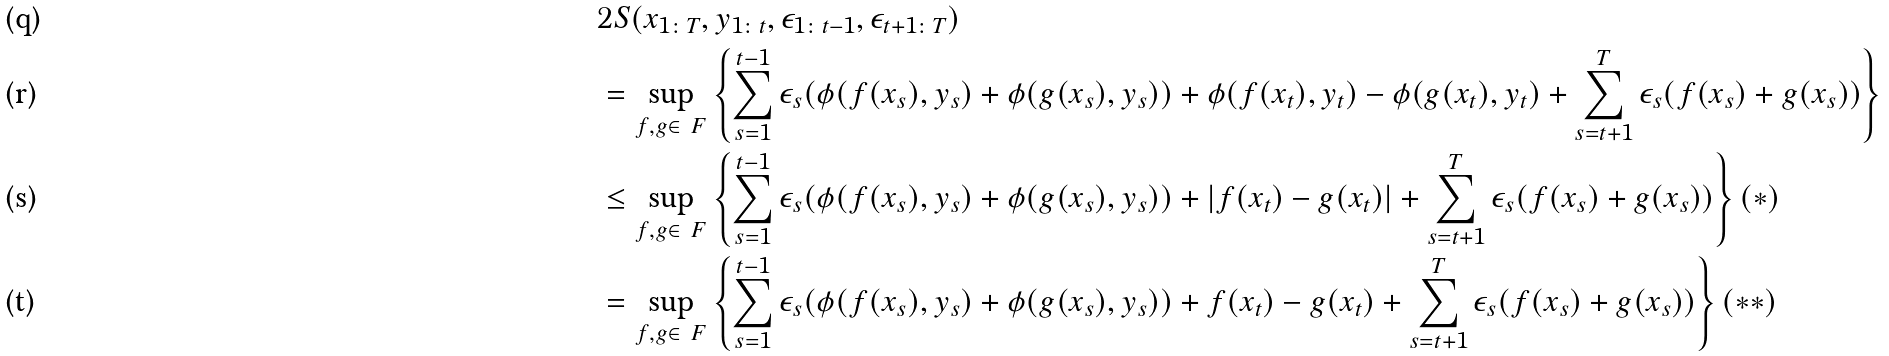<formula> <loc_0><loc_0><loc_500><loc_500>& 2 S ( x _ { 1 \colon T } , y _ { 1 \colon t } , \epsilon _ { 1 \colon t - 1 } , \epsilon _ { t + 1 \colon T } ) \\ & = \sup _ { f , g \in \ F } \left \{ \sum _ { s = 1 } ^ { t - 1 } \epsilon _ { s } ( \phi ( f ( x _ { s } ) , y _ { s } ) + \phi ( g ( x _ { s } ) , y _ { s } ) ) + \phi ( f ( x _ { t } ) , y _ { t } ) - \phi ( g ( x _ { t } ) , y _ { t } ) + \sum _ { s = t + 1 } ^ { T } \epsilon _ { s } ( f ( x _ { s } ) + g ( x _ { s } ) ) \right \} \\ & \leq \sup _ { f , g \in \ F } \left \{ \sum _ { s = 1 } ^ { t - 1 } \epsilon _ { s } ( \phi ( f ( x _ { s } ) , y _ { s } ) + \phi ( g ( x _ { s } ) , y _ { s } ) ) + | f ( x _ { t } ) - g ( x _ { t } ) | + \sum _ { s = t + 1 } ^ { T } \epsilon _ { s } ( f ( x _ { s } ) + g ( x _ { s } ) ) \right \} ( * ) \\ & = \sup _ { f , g \in \ F } \left \{ \sum _ { s = 1 } ^ { t - 1 } \epsilon _ { s } ( \phi ( f ( x _ { s } ) , y _ { s } ) + \phi ( g ( x _ { s } ) , y _ { s } ) ) + f ( x _ { t } ) - g ( x _ { t } ) + \sum _ { s = t + 1 } ^ { T } \epsilon _ { s } ( f ( x _ { s } ) + g ( x _ { s } ) ) \right \} ( * * )</formula> 